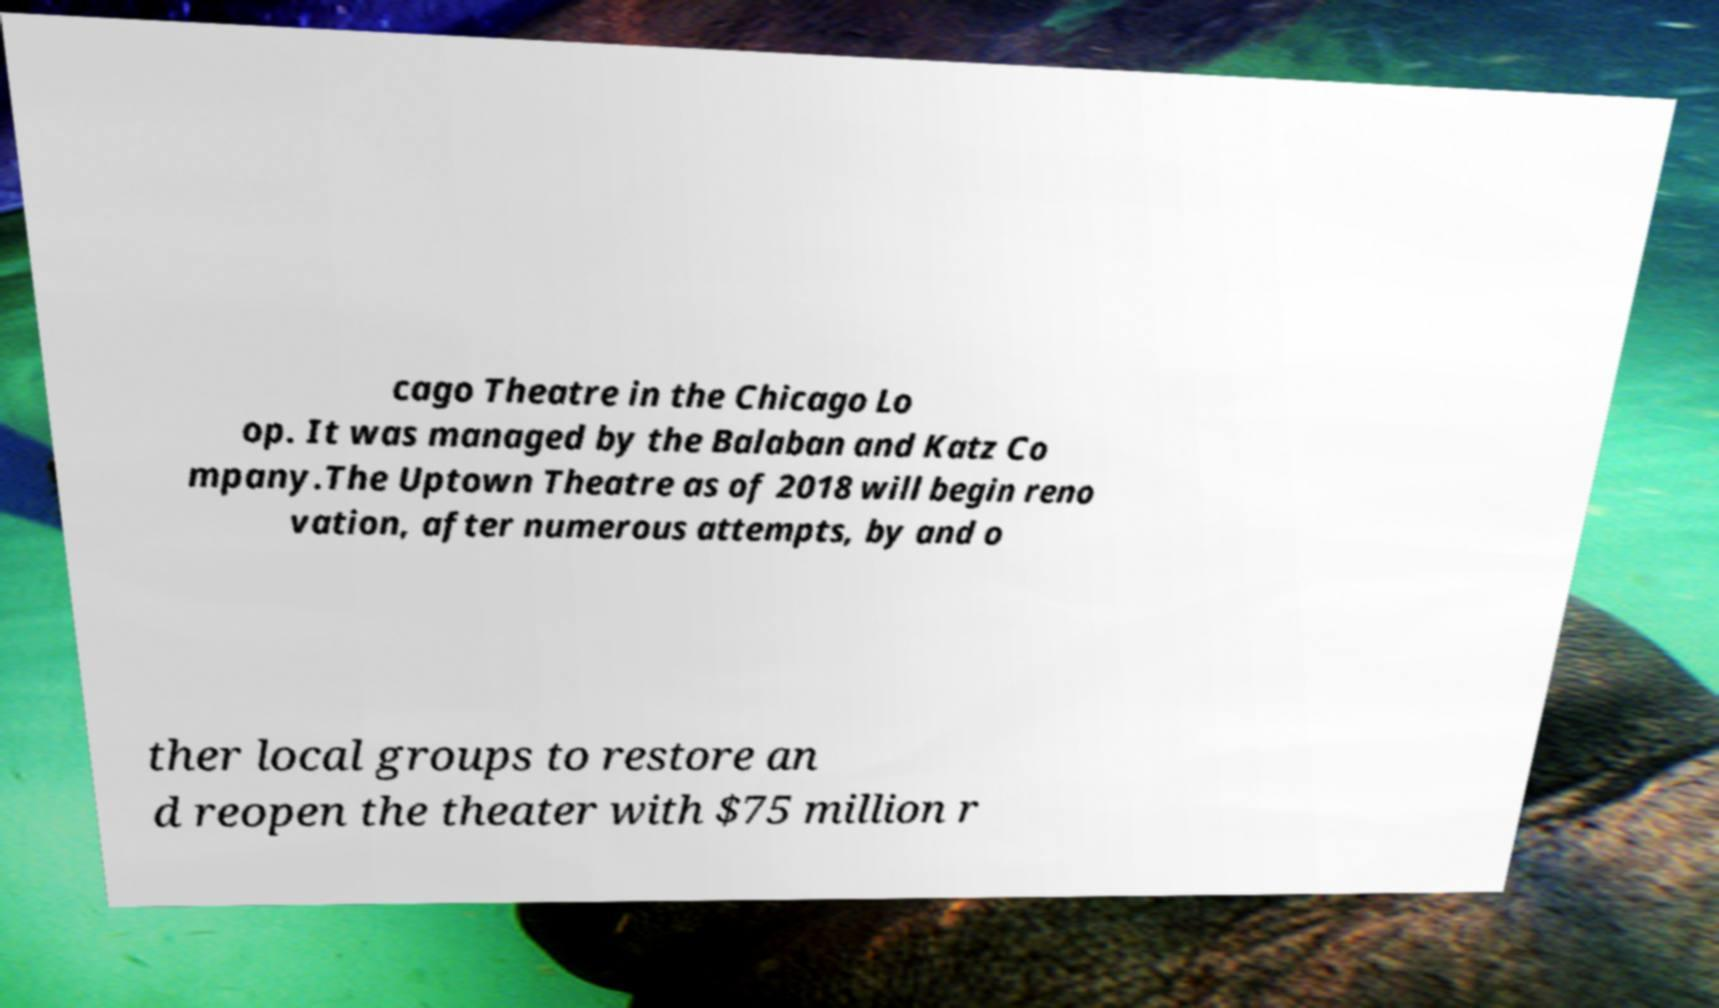Can you accurately transcribe the text from the provided image for me? cago Theatre in the Chicago Lo op. It was managed by the Balaban and Katz Co mpany.The Uptown Theatre as of 2018 will begin reno vation, after numerous attempts, by and o ther local groups to restore an d reopen the theater with $75 million r 